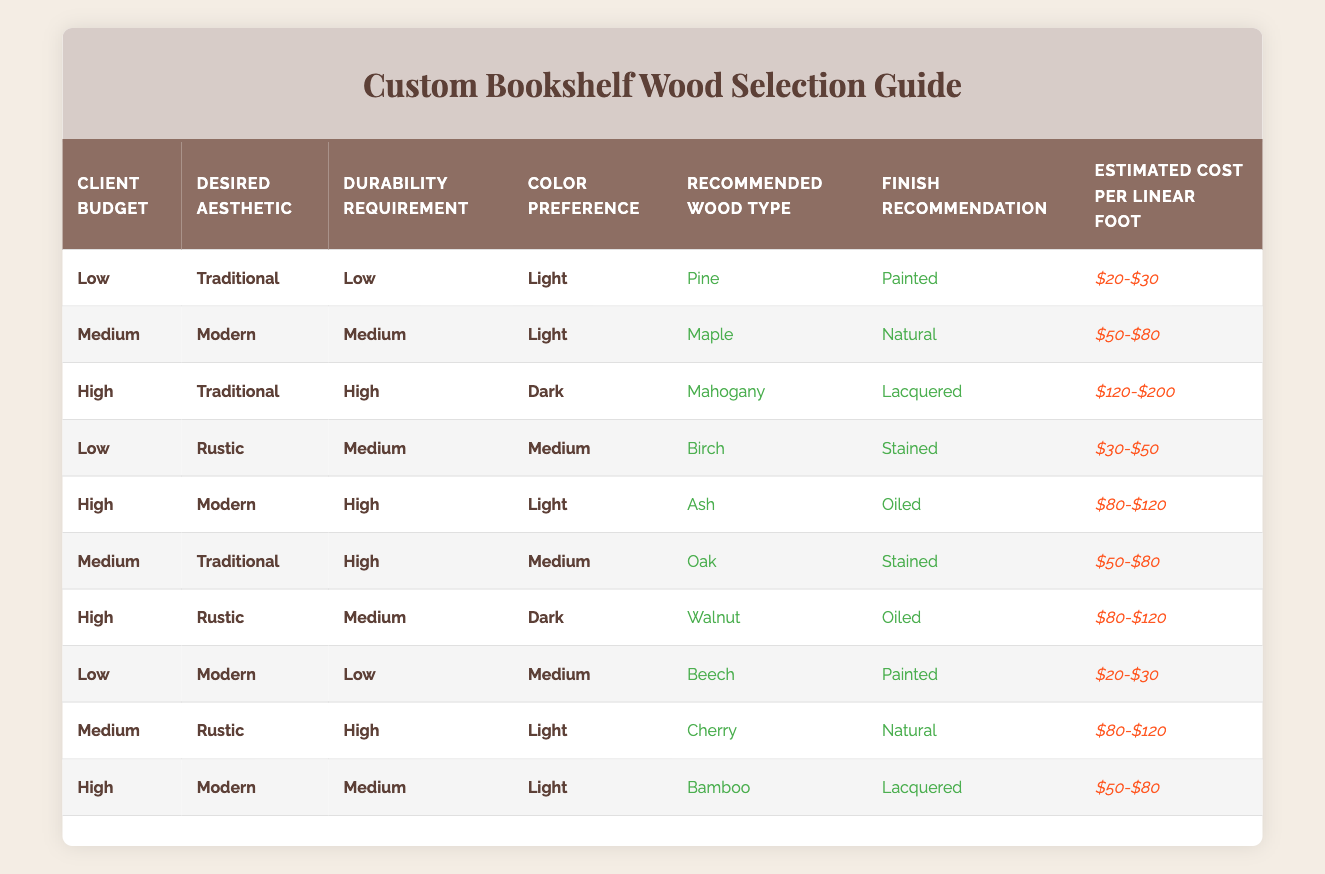What is the recommended wood type for a client with a low budget, who prefers a traditional aesthetic, has low durability requirements, and a light color preference? Looking at the table, there is a specific rule for a client budget labeled as "Low," with "Traditional" aesthetic, "Low" durability requirement, and "Light" color preference. This matches the first row in the table, which recommends "Pine" as the wood type.
Answer: Pine Is there a wood type recommended for a medium budget with a rustic aesthetic and high durability requirement? By filtering through the rules, I find that the second-to-last row provides a recommendation for a medium budget, rustic aesthetic, and high durability requirement. This row indicates "Cherry" as the recommended wood type.
Answer: Cherry What is the estimated cost per linear foot for a high budget, modern aesthetic, and medium durability requirement? The table indicates that for a "High" budget, "Modern" aesthetic, and "Medium" durability requirement, the corresponding row recommends "Bamboo" and states the estimated cost per linear foot as "$50-$80."
Answer: $50-$80 If a client desires a dark-colored wood and has a medium durability requirement, does the table provide a recommendation for either a low or medium budget? To answer this, I examine the table for both "Low" and "Medium" budget options that match a "Dark" color preference and "Medium" durability. Upon checking, I find that there is a "Low" budget option with a "Rustic" aesthetic that recommends "Walnut" and a "Medium" budget option does not provide a dark color preference. Thus, it shows that there is a recommendation for a low budget.
Answer: Yes Which wood type has the highest estimated cost per linear foot in the table? By scanning through the "Estimated Cost per Linear Foot" column in the table, I discover that "Mahogany" corresponds to the highest cost range of "$120-$200." This wood type is associated with high durability requirements and traditional aesthetics.
Answer: Mahogany How many different wood types are recommended for a high budget across all aesthetics? To determine how many wood types are recommended for a "High" budget, I will count the distinct wood types listed for that category in the table. The entries show "Mahogany," "Ash," "Walnut," and "Bamboo," totaling four different types.
Answer: 4 What is the recommended finish for medium-budget bookshelves with a modern aesthetic and medium durability? Referring to the table for "Medium" budget and "Modern" aesthetic with a "Medium" durability requirement, the corresponding recommendation is "Bamboo," with a "Lacquered" finish.
Answer: Lacquered Is the wood type "Beech" recommended for a low budget? I check the table for any entry involving "Beech" under the "Low" budget category. It appears in the section for "Modern" aesthetic, "Low" durability requirement, and "Medium" color preference, aligning it under the low budget category.
Answer: Yes 